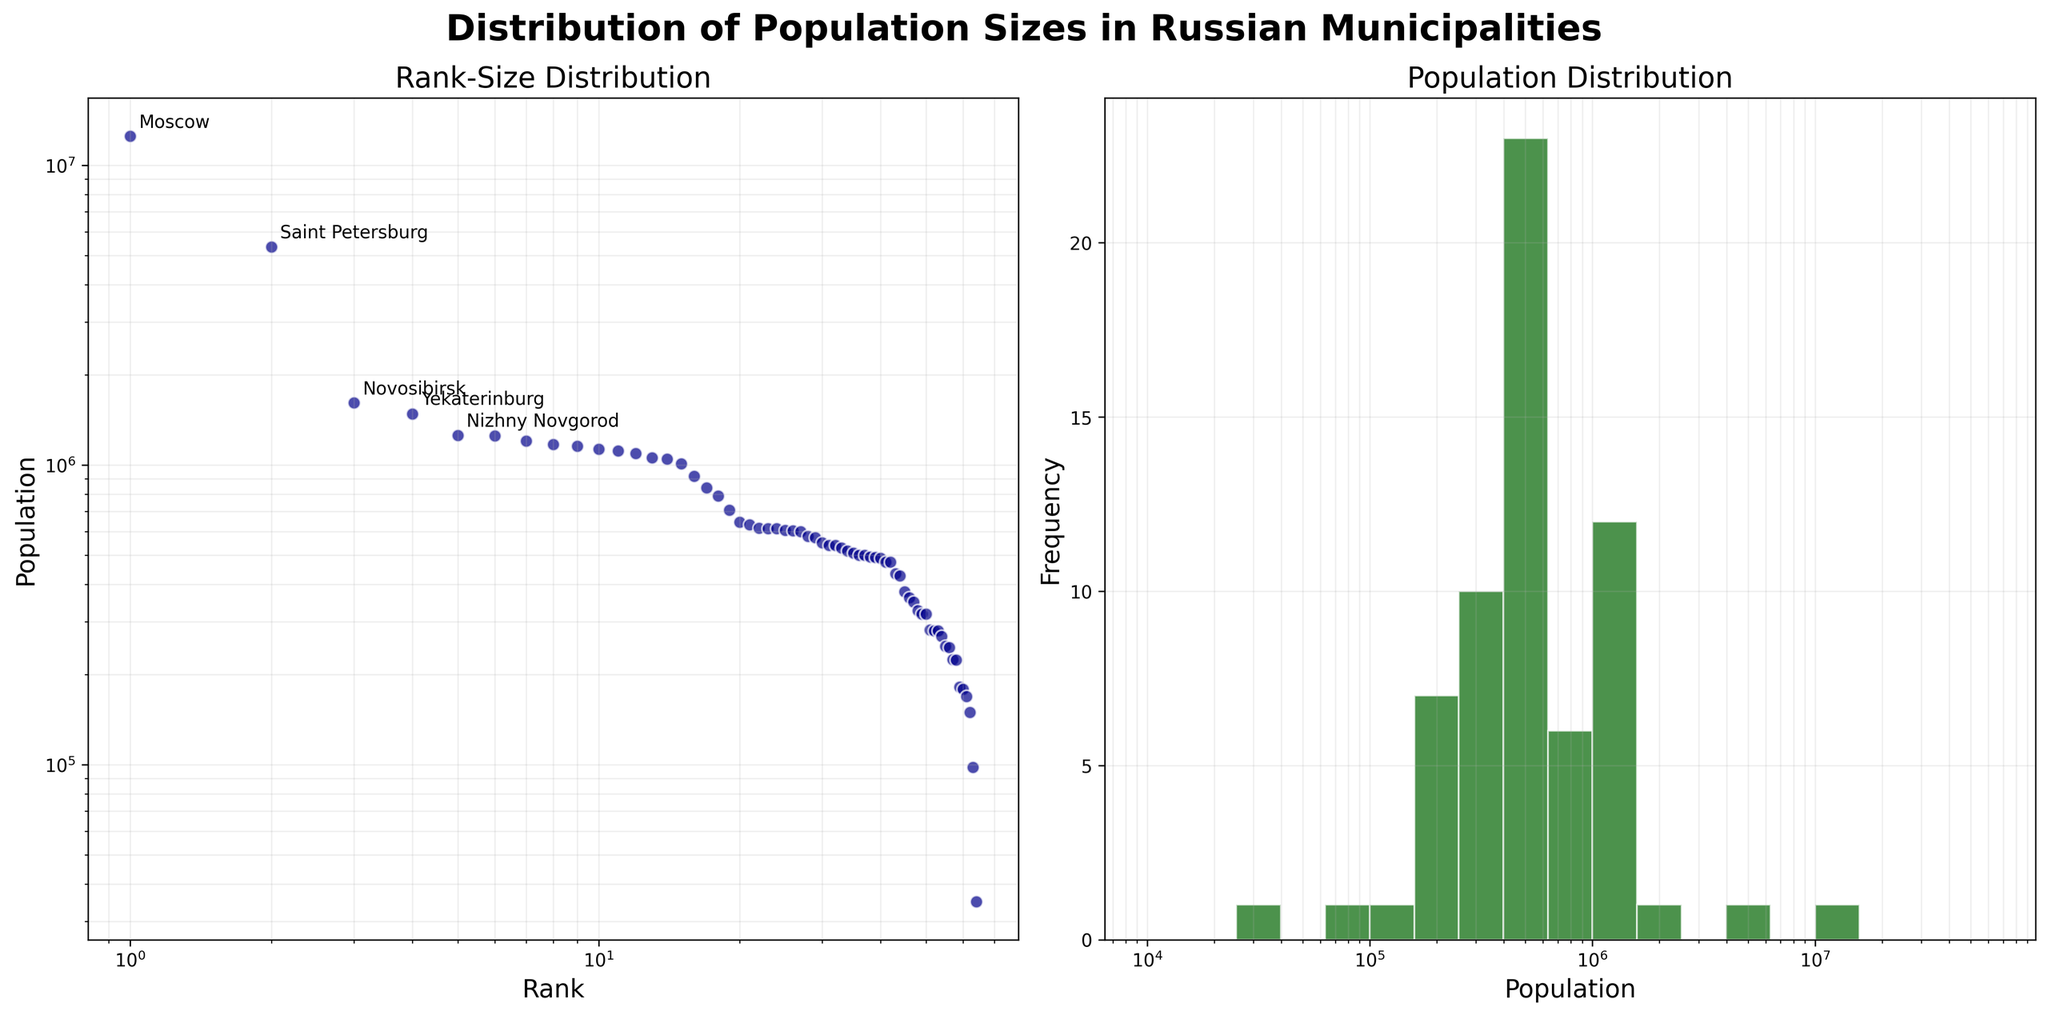What is the title of the figure? The title is written at the top of the figure and reads "Distribution of Population Sizes in Russian Municipalities".
Answer: Distribution of Population Sizes in Russian Municipalities What is the range of the x-axis in the rank-size distribution plot? On the rank-size distribution plot, the x-axis has a logarithmic scale and ranges from 1 to 100.
Answer: 1 to 100 Which city has the highest population, and what is its population? The city with the highest population is labeled in the rank-size distribution plot. It is Moscow with a population of 12,506,468.
Answer: Moscow, 12,506,468 How many bins are used in the population distribution histogram? The histogram appears to be divided into bins for population sizes, and counting them shows there are a total of 15 bins.
Answer: 15 What is the population range of municipalities within the highest frequency bin in the histogram? The bin with the highest bar represents the most frequent population range. In the population distribution histogram, the highest bin is located around 10^6 to 2*10^6.
Answer: Approximately 10^6 to 2*10^6 Compare and contrast the population sizes of Saint Petersburg and Novosibirsk. The rank-size distribution plot shows the populations of Saint Petersburg and Novosibirsk. Saint Petersburg has a population of 5,351,935, while Novosibirsk has a population of 1,612,833. Saint Petersburg's population is larger.
Answer: Saint Petersburg > Novosibirsk What is the typical population size range for the smaller rural areas? Observing the lower end of the population distribution histogram reveals that smaller rural areas usually fall within the population range from approximately 10^4 to 10^5.
Answer: Approximately 10^4 to 10^5 Identify the top 5 most populous municipalities and their respective populations. The rank-size distribution plot annotates the top 5 municipalities: Moscow (12,506,468), Saint Petersburg (5,351,935), Novosibirsk (1,612,833), Yekaterinburg (1,484,456), Nizhny Novgorod (1,250,615).
Answer: Moscow, Saint Petersburg, Novosibirsk, Yekaterinburg, Nizhny Novgorod How does the population size distribution differ between the largest urban centers and the smaller municipalities? The rank-size distribution plot shows a sharp decline in population size from the largest municipalities to smaller ones, indicating a steep inequality where a few urban centers have populations in the millions and most others have significantly smaller populations.
Answer: Sharp inequality Explain why a log-log scale is used in the rank-size distribution plot. A log-log scale is used to better visualize the large range of population sizes across municipalities. It compresses the large values and spreads out the smaller values, making patterns and differences in the data more apparent, especially for the urban centers versus rural areas.
Answer: Better visualization of large range of population sizes 